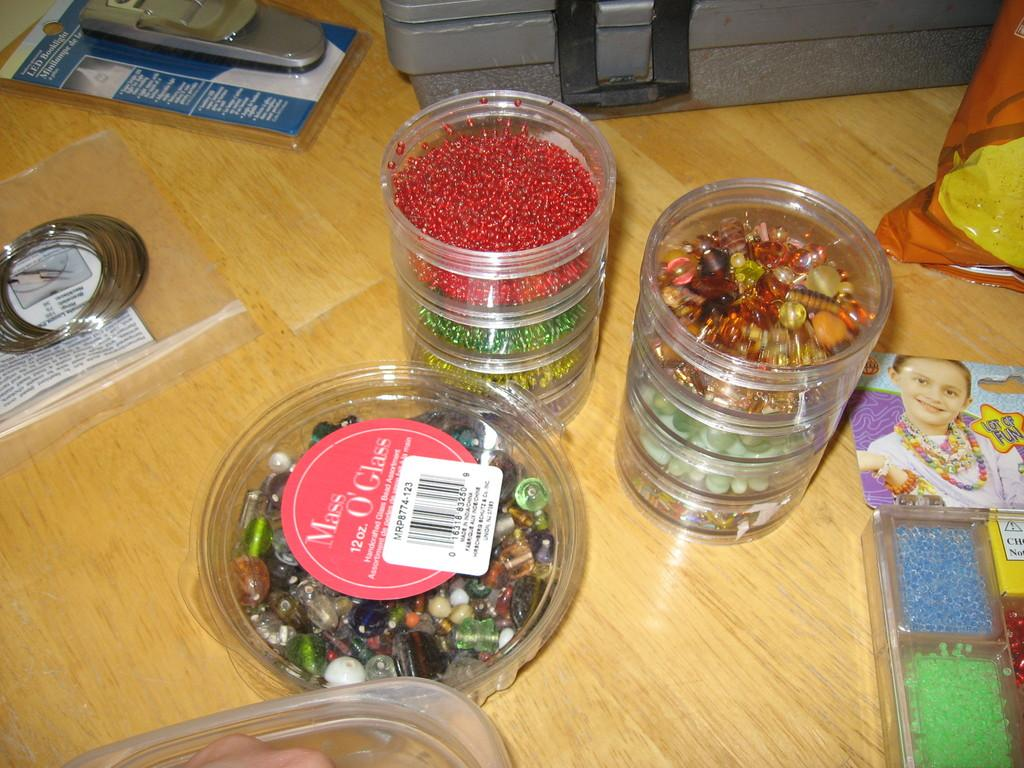What is on the wooden surface in the image? There are boxes, a suitcase, bangles, a container, and an unspecified object on the wooden surface. What is inside the boxes on the wooden surface? The boxes contain beads. What type of container is on the wooden surface? The container's contents are not specified in the image. What is the purpose of the bangles on the wooden surface? The purpose of the bangles is not specified in the image. How many quarters are visible on the wooden surface in the image? There are no quarters visible on the wooden surface in the image. What type of stitch is used to attach the bangles together in the image? The image does not show any stitching or attachment method for the bangles. 